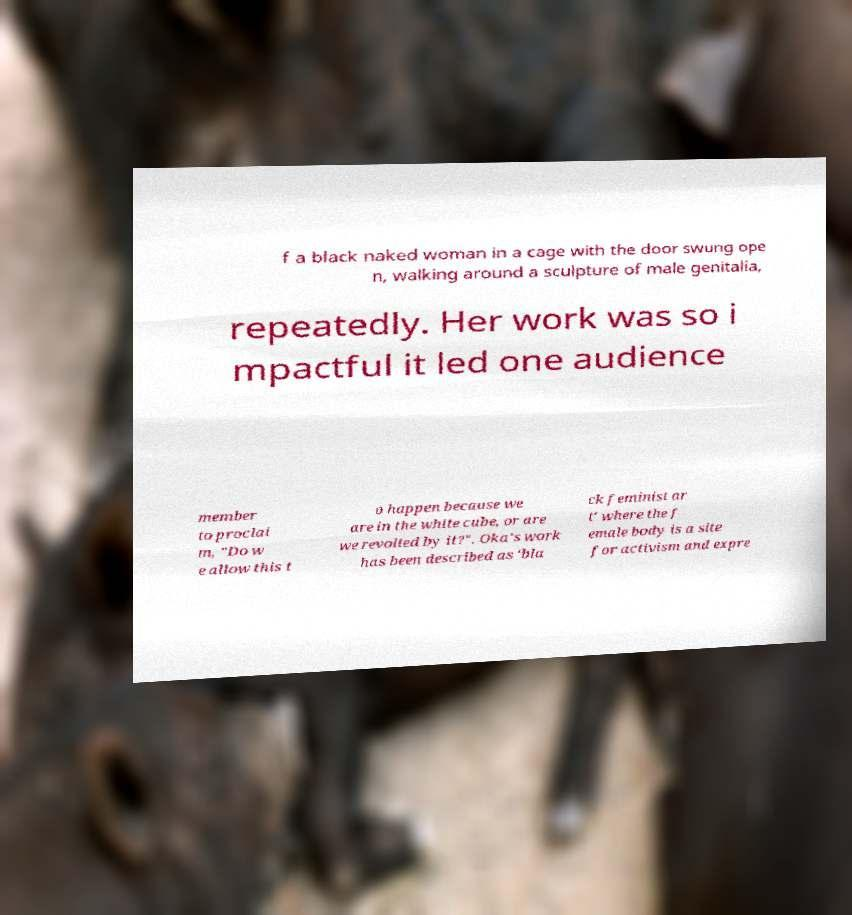There's text embedded in this image that I need extracted. Can you transcribe it verbatim? f a black naked woman in a cage with the door swung ope n, walking around a sculpture of male genitalia, repeatedly. Her work was so i mpactful it led one audience member to proclai m, "Do w e allow this t o happen because we are in the white cube, or are we revolted by it?". Oka's work has been described as 'bla ck feminist ar t' where the f emale body is a site for activism and expre 